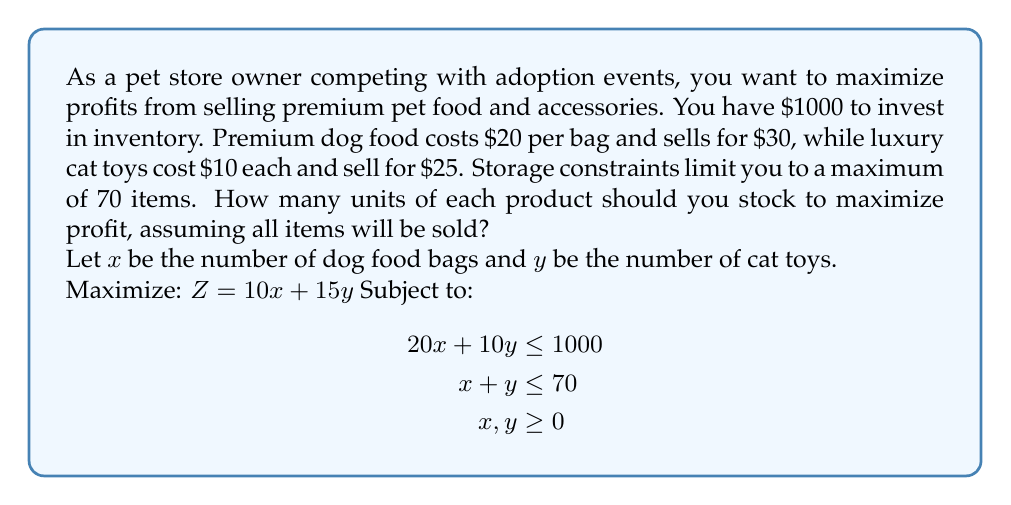What is the answer to this math problem? To solve this linear programming problem, we'll use the graphical method:

1) Plot the constraints:
   - Budget: $20x + 10y = 1000$ or $y = 100 - 2x$
   - Storage: $x + y = 70$
   - Non-negativity: $x \geq 0$, $y \geq 0$

2) Identify the feasible region (the area that satisfies all constraints).

3) Find the corner points of the feasible region:
   A (0, 70), B (0, 100), C (50, 0), D (35, 35)

4) Evaluate the objective function $Z = 10x + 15y$ at each corner point:
   A: $Z = 10(0) + 15(70) = 1050$
   B: $Z = 10(0) + 15(100) = 1500$
   C: $Z = 10(50) + 15(0) = 500$
   D: $Z = 10(35) + 15(35) = 875$

5) The maximum value occurs at point B (0, 100), but this violates the storage constraint.

6) The next best point that satisfies all constraints is D (35, 35).

Therefore, to maximize profit, stock 35 bags of dog food and 35 cat toys.
Answer: 35 bags of dog food, 35 cat toys 